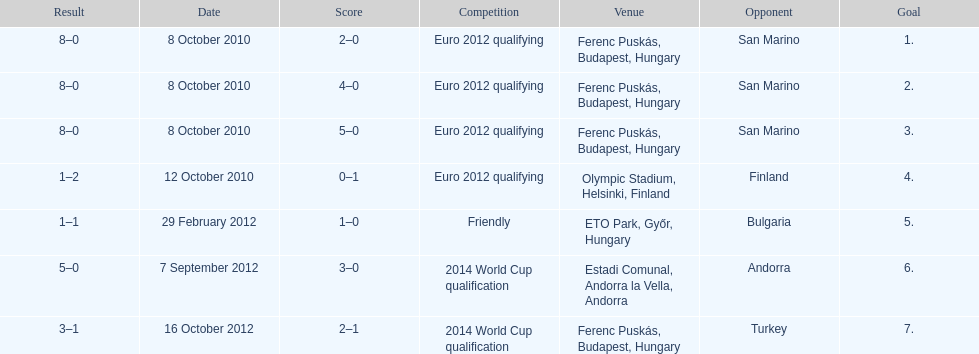In what year was szalai's first international goal? 2010. Parse the full table. {'header': ['Result', 'Date', 'Score', 'Competition', 'Venue', 'Opponent', 'Goal'], 'rows': [['8–0', '8 October 2010', '2–0', 'Euro 2012 qualifying', 'Ferenc Puskás, Budapest, Hungary', 'San Marino', '1.'], ['8–0', '8 October 2010', '4–0', 'Euro 2012 qualifying', 'Ferenc Puskás, Budapest, Hungary', 'San Marino', '2.'], ['8–0', '8 October 2010', '5–0', 'Euro 2012 qualifying', 'Ferenc Puskás, Budapest, Hungary', 'San Marino', '3.'], ['1–2', '12 October 2010', '0–1', 'Euro 2012 qualifying', 'Olympic Stadium, Helsinki, Finland', 'Finland', '4.'], ['1–1', '29 February 2012', '1–0', 'Friendly', 'ETO Park, Győr, Hungary', 'Bulgaria', '5.'], ['5–0', '7 September 2012', '3–0', '2014 World Cup qualification', 'Estadi Comunal, Andorra la Vella, Andorra', 'Andorra', '6.'], ['3–1', '16 October 2012', '2–1', '2014 World Cup qualification', 'Ferenc Puskás, Budapest, Hungary', 'Turkey', '7.']]} 